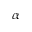<formula> <loc_0><loc_0><loc_500><loc_500>\alpha</formula> 